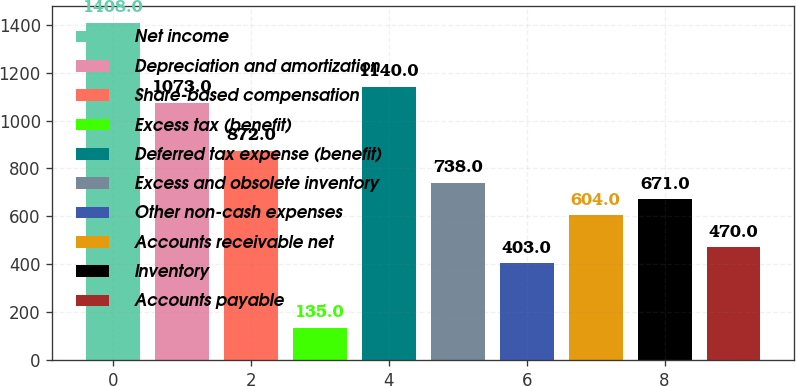Convert chart. <chart><loc_0><loc_0><loc_500><loc_500><bar_chart><fcel>Net income<fcel>Depreciation and amortization<fcel>Share-based compensation<fcel>Excess tax (benefit)<fcel>Deferred tax expense (benefit)<fcel>Excess and obsolete inventory<fcel>Other non-cash expenses<fcel>Accounts receivable net<fcel>Inventory<fcel>Accounts payable<nl><fcel>1408<fcel>1073<fcel>872<fcel>135<fcel>1140<fcel>738<fcel>403<fcel>604<fcel>671<fcel>470<nl></chart> 